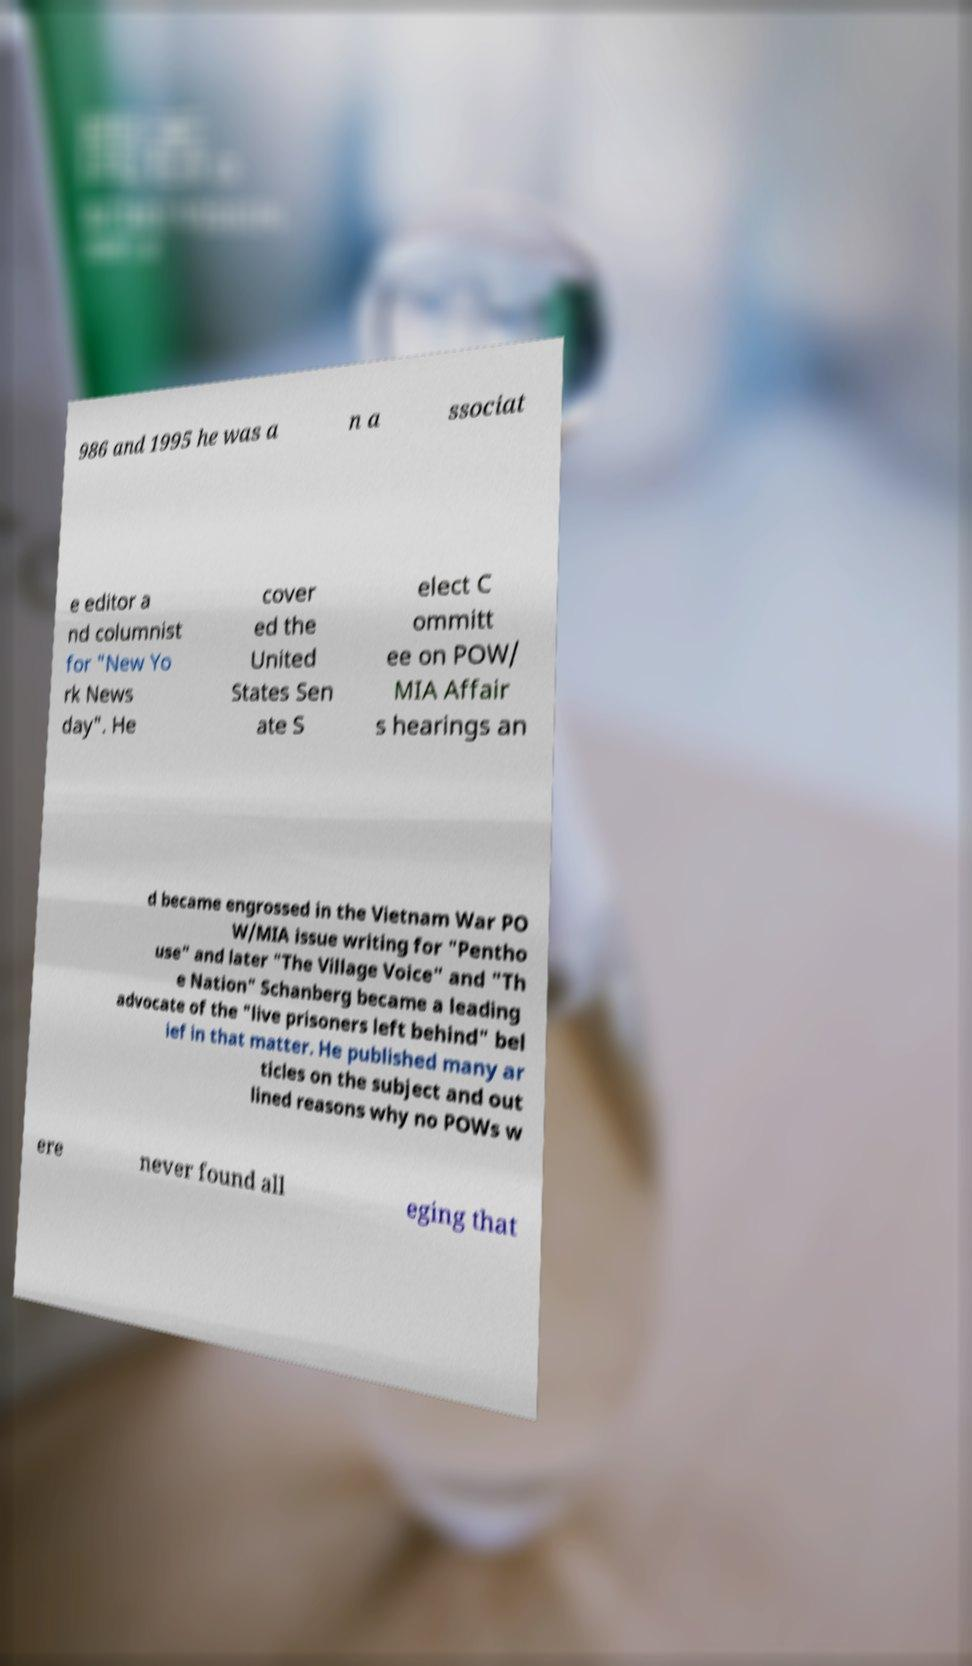Please identify and transcribe the text found in this image. 986 and 1995 he was a n a ssociat e editor a nd columnist for "New Yo rk News day". He cover ed the United States Sen ate S elect C ommitt ee on POW/ MIA Affair s hearings an d became engrossed in the Vietnam War PO W/MIA issue writing for "Pentho use" and later "The Village Voice" and "Th e Nation" Schanberg became a leading advocate of the "live prisoners left behind" bel ief in that matter. He published many ar ticles on the subject and out lined reasons why no POWs w ere never found all eging that 